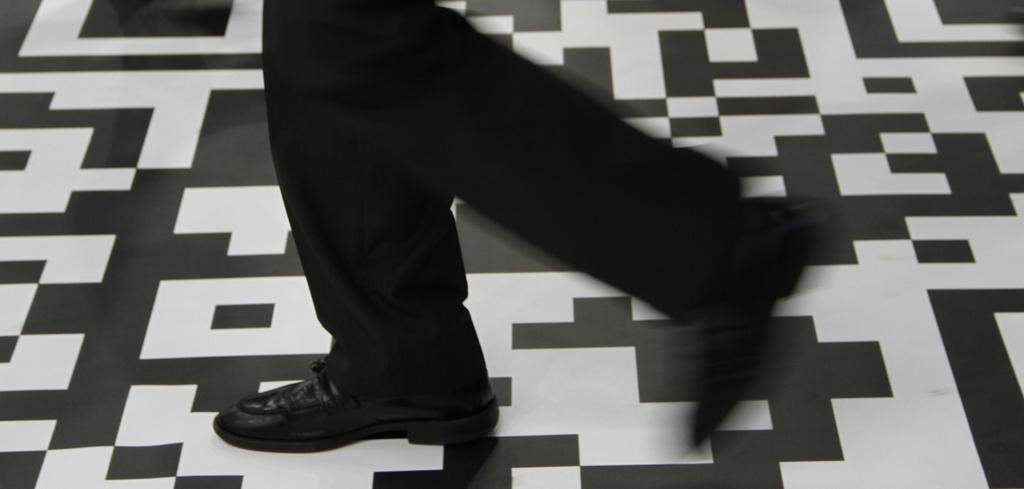What body part is visible in the image? There are person's legs visible in the image. Where are the legs located? The legs are on the floor. What type of vessel is being played in harmony by the person's eyes in the image? There is no vessel or person's eyes playing a musical instrument in the image; only the person's legs are visible. 